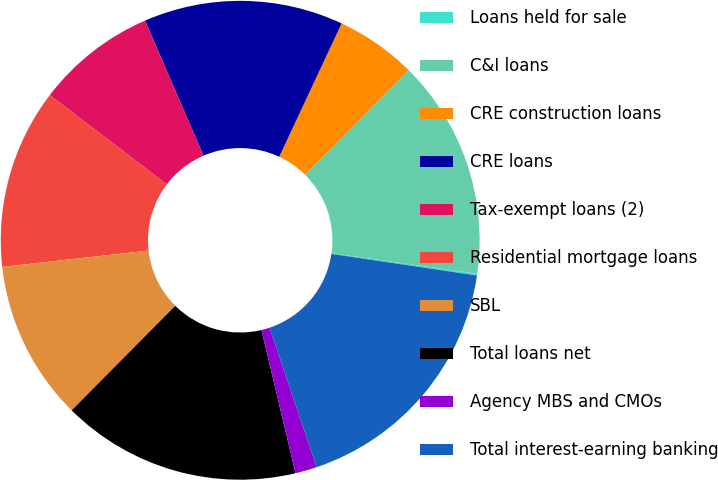<chart> <loc_0><loc_0><loc_500><loc_500><pie_chart><fcel>Loans held for sale<fcel>C&I loans<fcel>CRE construction loans<fcel>CRE loans<fcel>Tax-exempt loans (2)<fcel>Residential mortgage loans<fcel>SBL<fcel>Total loans net<fcel>Agency MBS and CMOs<fcel>Total interest-earning banking<nl><fcel>0.12%<fcel>14.81%<fcel>5.46%<fcel>13.47%<fcel>8.13%<fcel>12.14%<fcel>10.8%<fcel>16.14%<fcel>1.46%<fcel>17.48%<nl></chart> 